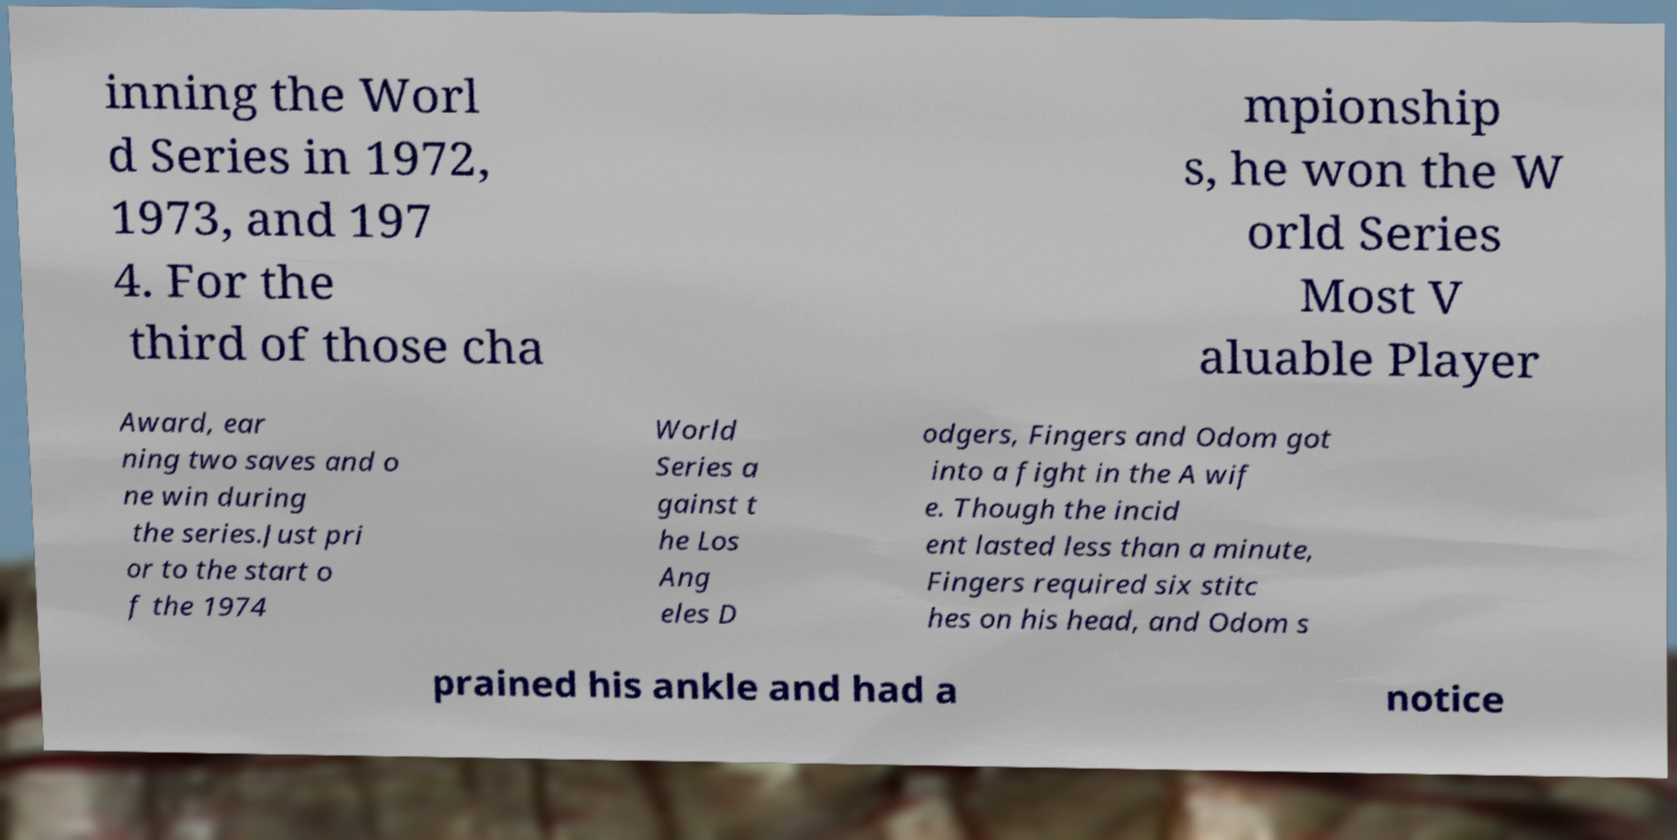Could you extract and type out the text from this image? inning the Worl d Series in 1972, 1973, and 197 4. For the third of those cha mpionship s, he won the W orld Series Most V aluable Player Award, ear ning two saves and o ne win during the series.Just pri or to the start o f the 1974 World Series a gainst t he Los Ang eles D odgers, Fingers and Odom got into a fight in the A wif e. Though the incid ent lasted less than a minute, Fingers required six stitc hes on his head, and Odom s prained his ankle and had a notice 